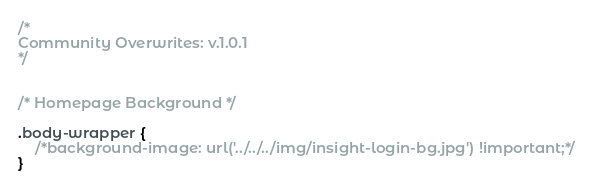<code> <loc_0><loc_0><loc_500><loc_500><_CSS_>/* 
Community Overwrites: v.1.0.1
*/


/* Homepage Background */

.body-wrapper {
    /*background-image: url('../../../img/insight-login-bg.jpg') !important;*/
}
</code> 